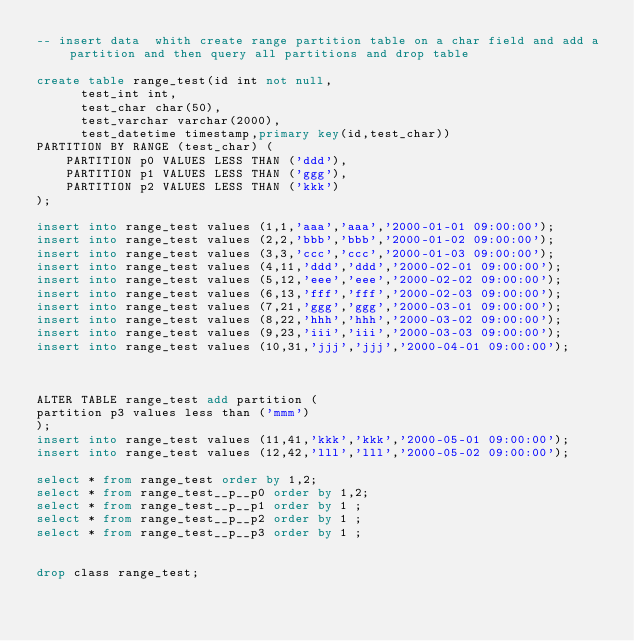Convert code to text. <code><loc_0><loc_0><loc_500><loc_500><_SQL_>-- insert data  whith create range partition table on a char field and add a partition and then query all partitions and drop table

create table range_test(id int not null,
			test_int int,
			test_char char(50),
			test_varchar varchar(2000),
			test_datetime timestamp,primary key(id,test_char))
PARTITION BY RANGE (test_char) (
    PARTITION p0 VALUES LESS THAN ('ddd'),
    PARTITION p1 VALUES LESS THAN ('ggg'),
    PARTITION p2 VALUES LESS THAN ('kkk')
);

insert into range_test values (1,1,'aaa','aaa','2000-01-01 09:00:00');
insert into range_test values (2,2,'bbb','bbb','2000-01-02 09:00:00');
insert into range_test values (3,3,'ccc','ccc','2000-01-03 09:00:00');
insert into range_test values (4,11,'ddd','ddd','2000-02-01 09:00:00');
insert into range_test values (5,12,'eee','eee','2000-02-02 09:00:00');
insert into range_test values (6,13,'fff','fff','2000-02-03 09:00:00');
insert into range_test values (7,21,'ggg','ggg','2000-03-01 09:00:00');
insert into range_test values (8,22,'hhh','hhh','2000-03-02 09:00:00');
insert into range_test values (9,23,'iii','iii','2000-03-03 09:00:00');
insert into range_test values (10,31,'jjj','jjj','2000-04-01 09:00:00');



ALTER TABLE range_test add partition (
partition p3 values less than ('mmm')
);
insert into range_test values (11,41,'kkk','kkk','2000-05-01 09:00:00');
insert into range_test values (12,42,'lll','lll','2000-05-02 09:00:00');

select * from range_test order by 1,2;
select * from range_test__p__p0 order by 1,2;
select * from range_test__p__p1 order by 1 ;
select * from range_test__p__p2 order by 1 ;
select * from range_test__p__p3 order by 1 ;


drop class range_test;
</code> 